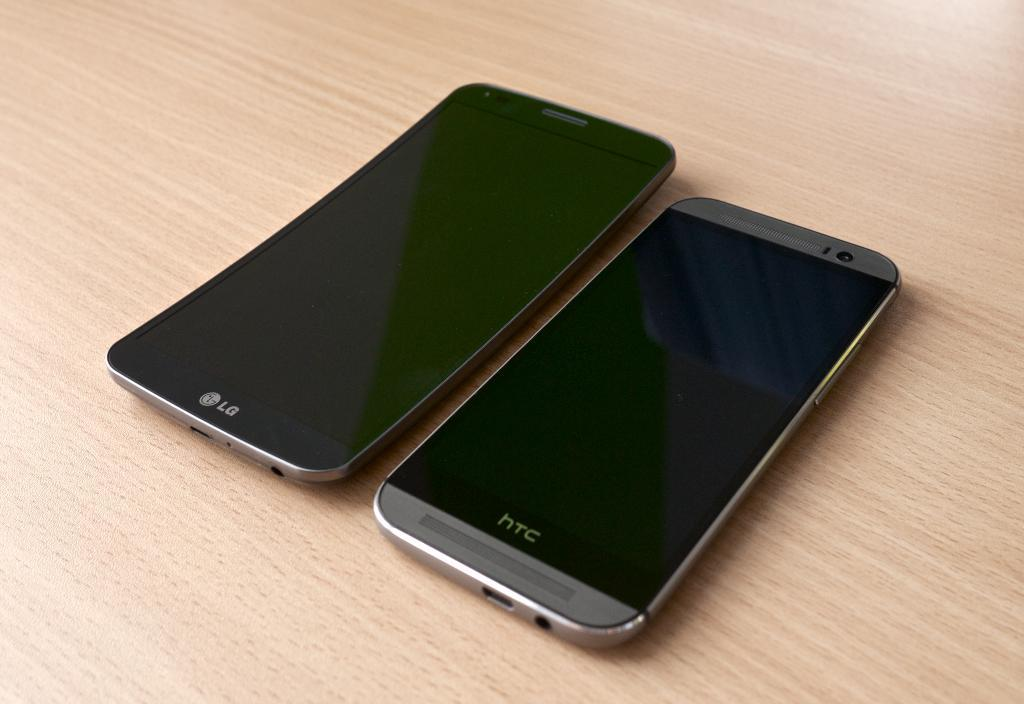<image>
Summarize the visual content of the image. Black LG phone next to a silver HTC phone. 